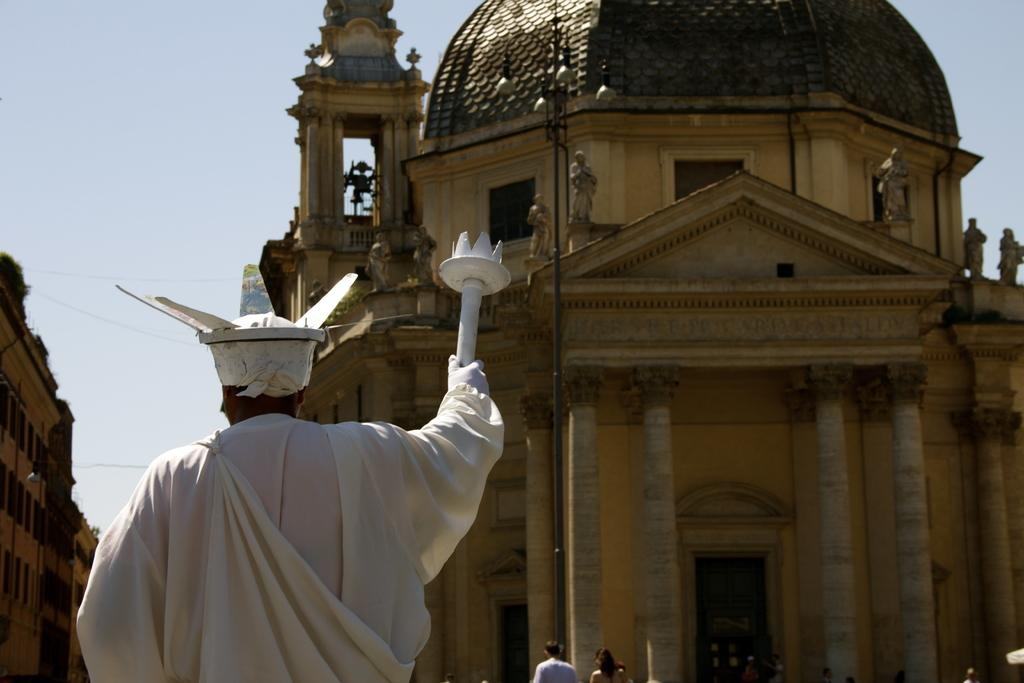What is located on the left side of the image? There is a statue on the left side of the image. What can be seen in the background of the image? There are buildings and the sky visible in the background of the image. How many zebras can be seen grazing in the background of the image? There are no zebras present in the image; it features a statue and buildings in the background. What is the temperature like in the image? The temperature cannot be determined from the image, as there is no information about the weather or climate provided. 